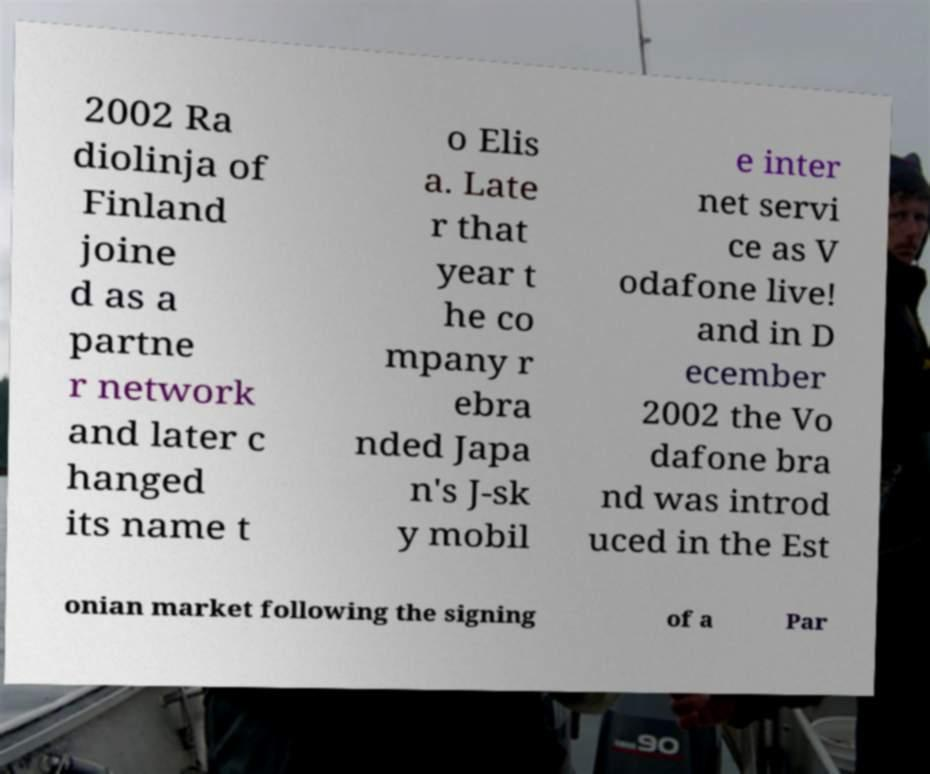Could you extract and type out the text from this image? 2002 Ra diolinja of Finland joine d as a partne r network and later c hanged its name t o Elis a. Late r that year t he co mpany r ebra nded Japa n's J-sk y mobil e inter net servi ce as V odafone live! and in D ecember 2002 the Vo dafone bra nd was introd uced in the Est onian market following the signing of a Par 